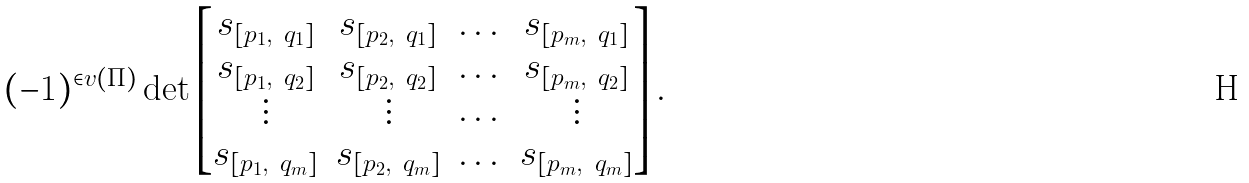<formula> <loc_0><loc_0><loc_500><loc_500>( - 1 ) ^ { \in v ( \Pi ) } \det \left [ \begin{matrix} s _ { [ p _ { 1 } , \ q _ { 1 } ] } & s _ { [ p _ { 2 } , \ q _ { 1 } ] } & \dots & s _ { [ p _ { m } , \ q _ { 1 } ] } \\ s _ { [ p _ { 1 } , \ q _ { 2 } ] } & s _ { [ p _ { 2 } , \ q _ { 2 } ] } & \dots & s _ { [ p _ { m } , \ q _ { 2 } ] } \\ \vdots & \vdots & \dots & \vdots \\ s _ { [ p _ { 1 } , \ q _ { m } ] } & s _ { [ p _ { 2 } , \ q _ { m } ] } & \dots & s _ { [ p _ { m } , \ q _ { m } ] } \end{matrix} \right ] .</formula> 